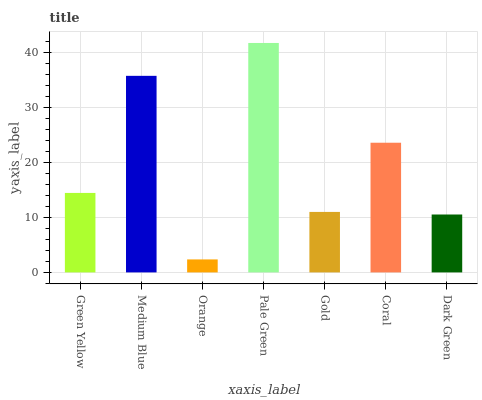Is Orange the minimum?
Answer yes or no. Yes. Is Pale Green the maximum?
Answer yes or no. Yes. Is Medium Blue the minimum?
Answer yes or no. No. Is Medium Blue the maximum?
Answer yes or no. No. Is Medium Blue greater than Green Yellow?
Answer yes or no. Yes. Is Green Yellow less than Medium Blue?
Answer yes or no. Yes. Is Green Yellow greater than Medium Blue?
Answer yes or no. No. Is Medium Blue less than Green Yellow?
Answer yes or no. No. Is Green Yellow the high median?
Answer yes or no. Yes. Is Green Yellow the low median?
Answer yes or no. Yes. Is Gold the high median?
Answer yes or no. No. Is Medium Blue the low median?
Answer yes or no. No. 